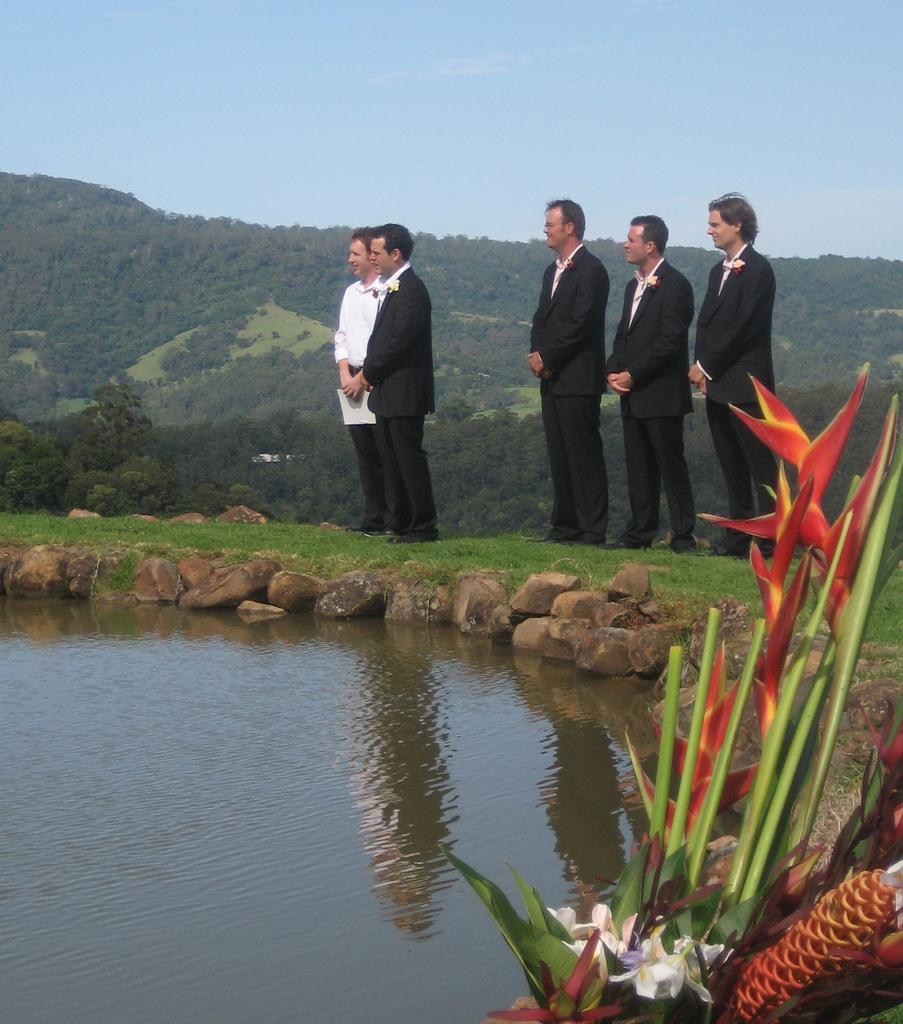Please provide a concise description of this image. In this image we can see a few people standing on the grass, behind them, we can see water, some flowers, small stones, there in the background we can see few mountains, few trees. 